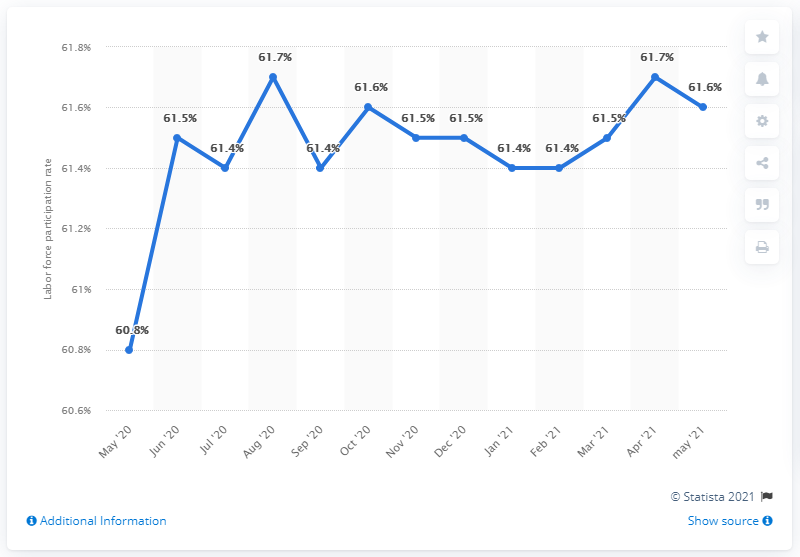Outline some significant characteristics in this image. The largest increase occurred during the month of June 2020. The chart is expected to reach its peak in August 2020 and April 2021. 